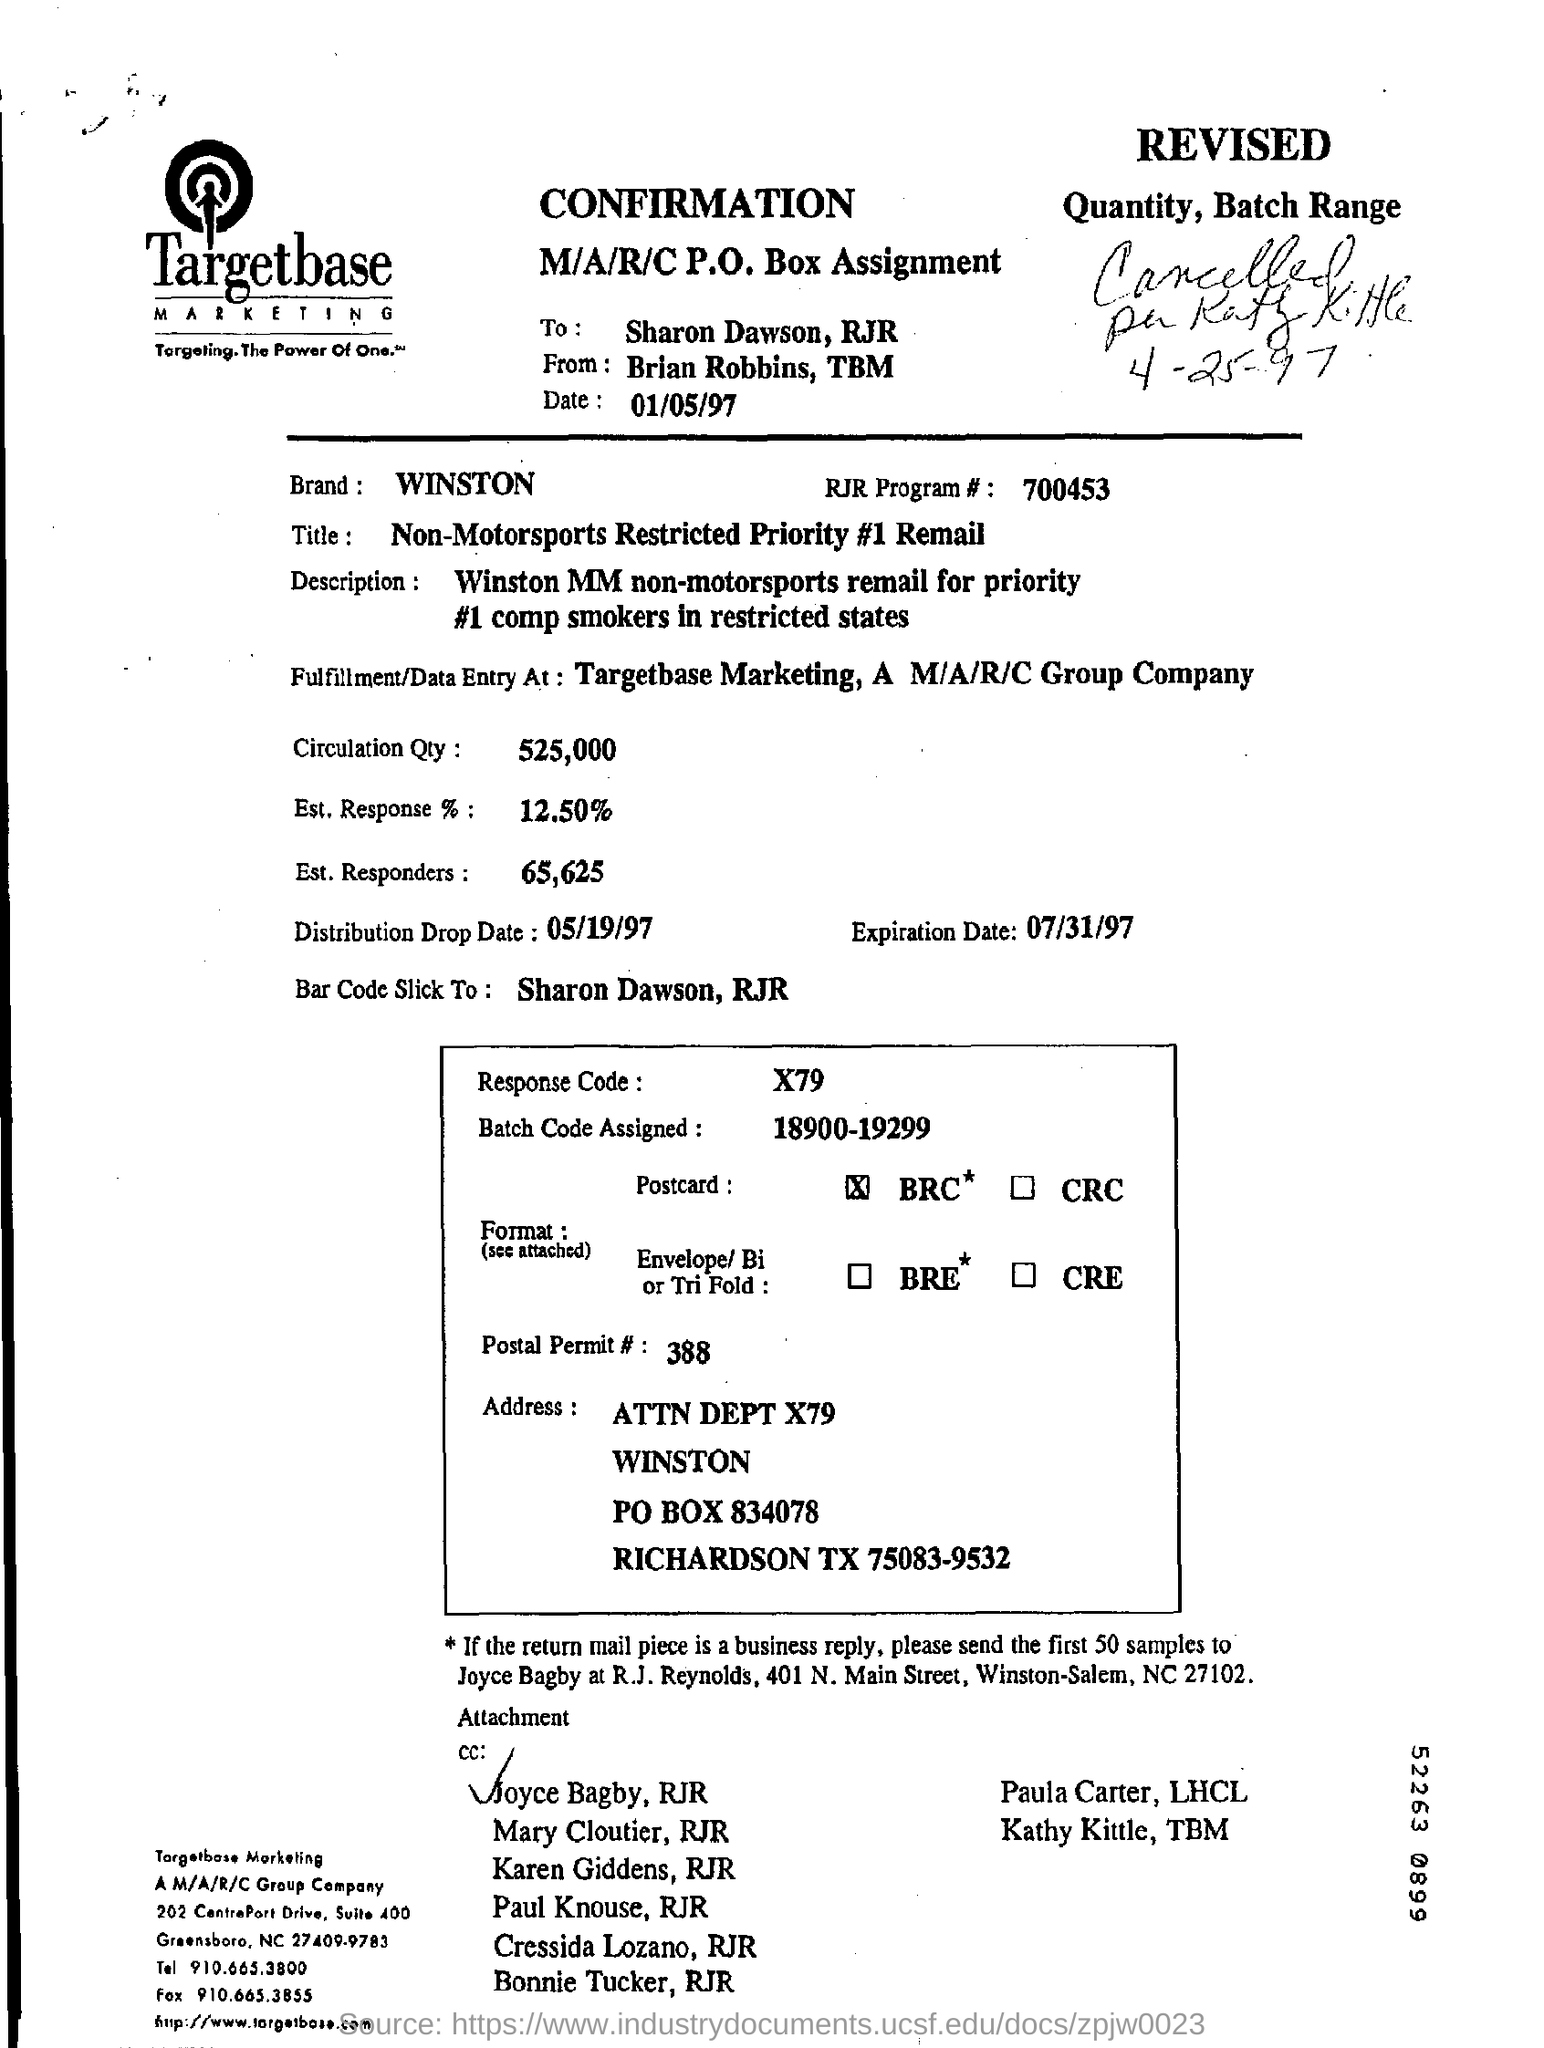List a handful of essential elements in this visual. This confirmation sheet belongs to Targetbase Marketing. This message is from Brain Robbins of TBM. The response code given is X79. 